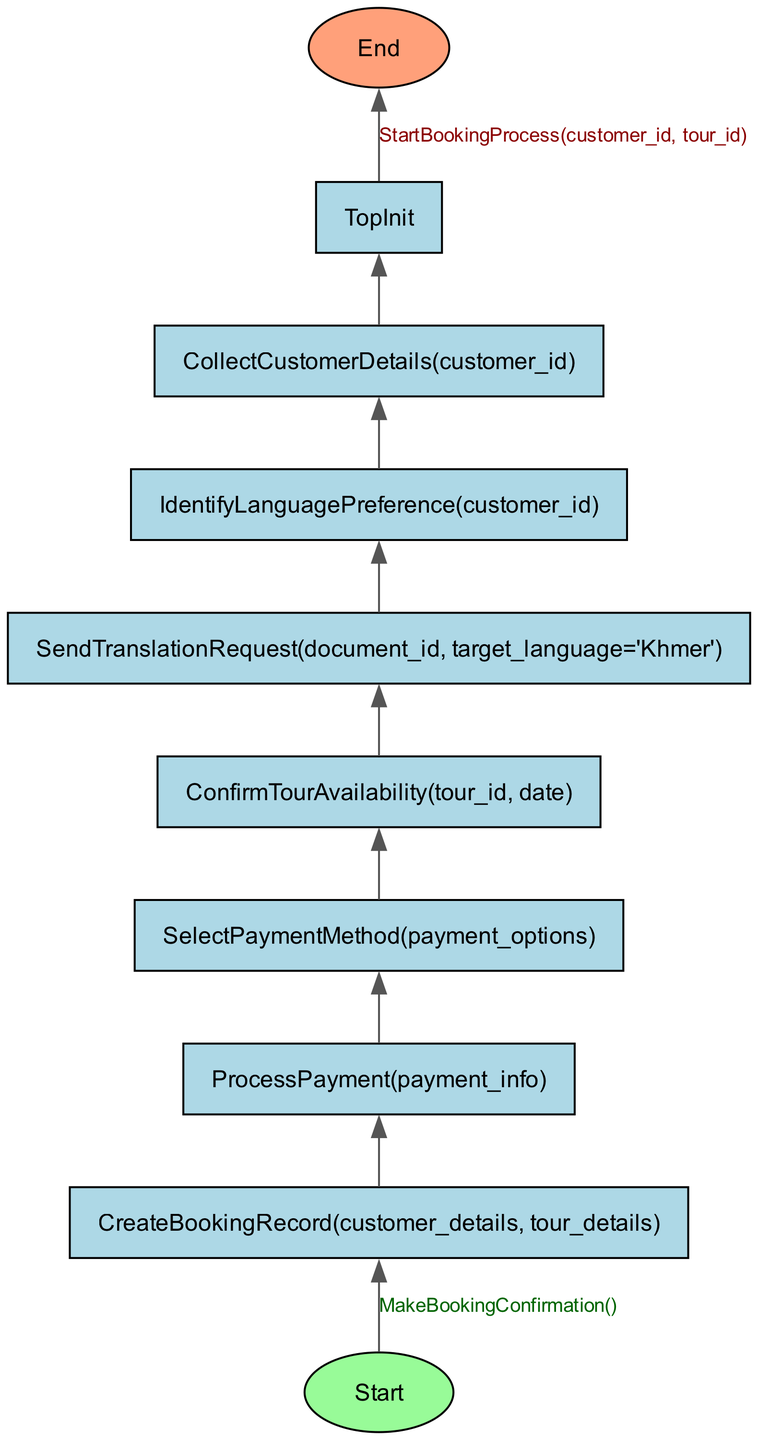What is the first step in the booking process? The diagram starts with the node labeled 'Start' which connects to 'CreateBookingRecord'. This indicates that 'CreateBookingRecord' is the first action performed in the booking process.
Answer: CreateBookingRecord How many steps are involved in the booking process? By counting the nodes that are interconnected, there are a total of seven steps from 'CreateBookingRecord' to 'CollectCustomerDetails' leading up to the final confirmation and payment processing.
Answer: Seven What is the last step before confirming the tour? The last step before reaching the confirmation is represented by the node 'SendTranslationRequest', which signifies that translation requests need to be sent prior to confirming the tour.
Answer: SendTranslationRequest Which node comes just before 'ProcessPayment'? In the flowchart, 'ProcessPayment' is directly preceded by 'CreateBookingRecord', indicating that a booking record must be created first before payment can be processed.
Answer: CreateBookingRecord How does the process return to the start? The process ends at 'End', which connects back to the 'Start' node through 'TopInit', indicating that once all steps are completed, the process can restart.
Answer: TopInit What node represents the identification of customer preferences? The node designated for this purpose is 'IdentifyLanguagePreference', which indicates the step of recognizing the customer's language requirements in the booking process.
Answer: IdentifyLanguagePreference What is the relationship between 'ConfirmTourAvailability' and 'SelectPaymentMethod'? The diagram shows a directional flow from ‘SelectPaymentMethod’ to ‘ConfirmTourAvailability’, indicating that selecting a payment method occurs prior to confirming availability of the tour.
Answer: ConfirmTourAvailability What is the action taken after 'CollectCustomerDetails'? After 'CollectCustomerDetails', the next action taken in the process is 'IdentifyLanguagePreference', requirements for recognizing language preferences following customer data collection.
Answer: IdentifyLanguagePreference How many edges are there in the diagram? By analyzing the flowchart, we can determine that there are a total of six edges that connect the nodes, illustrating the flow of actions in the booking process.
Answer: Six 